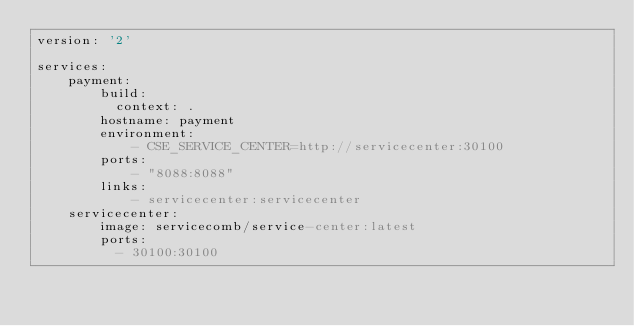<code> <loc_0><loc_0><loc_500><loc_500><_YAML_>version: '2'

services:
    payment:
        build: 
          context: .
        hostname: payment
        environment:
            - CSE_SERVICE_CENTER=http://servicecenter:30100
        ports:
            - "8088:8088"
        links:
            - servicecenter:servicecenter
    servicecenter:
        image: servicecomb/service-center:latest
        ports:
          - 30100:30100</code> 